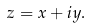<formula> <loc_0><loc_0><loc_500><loc_500>z = x + i y .</formula> 